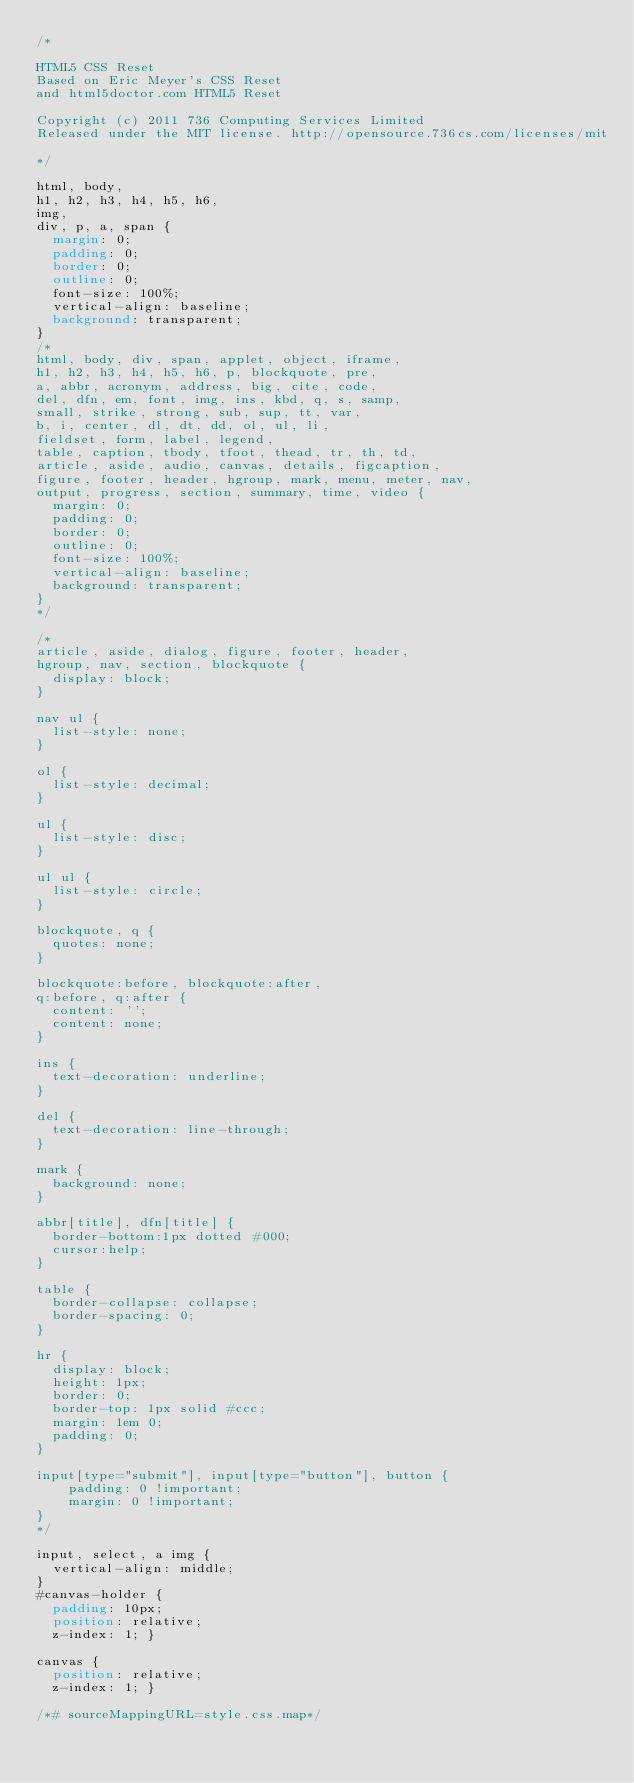<code> <loc_0><loc_0><loc_500><loc_500><_CSS_>/*

HTML5 CSS Reset
Based on Eric Meyer's CSS Reset
and html5doctor.com HTML5 Reset

Copyright (c) 2011 736 Computing Services Limited
Released under the MIT license. http://opensource.736cs.com/licenses/mit

*/

html, body,
h1, h2, h3, h4, h5, h6,
img,
div, p, a, span {
	margin: 0;
	padding: 0;
	border: 0;
	outline: 0;
	font-size: 100%;
	vertical-align: baseline;
	background: transparent;
}
/*
html, body, div, span, applet, object, iframe,
h1, h2, h3, h4, h5, h6, p, blockquote, pre,
a, abbr, acronym, address, big, cite, code,
del, dfn, em, font, img, ins, kbd, q, s, samp,
small, strike, strong, sub, sup, tt, var,
b, i, center, dl, dt, dd, ol, ul, li,
fieldset, form, label, legend,
table, caption, tbody, tfoot, thead, tr, th, td,
article, aside, audio, canvas, details, figcaption,
figure, footer, header, hgroup, mark, menu, meter, nav,
output, progress, section, summary, time, video {
	margin: 0;
	padding: 0;
	border: 0;
	outline: 0;
	font-size: 100%;
	vertical-align: baseline;
	background: transparent;
}
*/

/*
article, aside, dialog, figure, footer, header,
hgroup, nav, section, blockquote {
	display: block;
}

nav ul {
	list-style: none;
}

ol {
	list-style: decimal;
}

ul {
	list-style: disc;
}

ul ul {
	list-style: circle;
}

blockquote, q {
	quotes: none;
}

blockquote:before, blockquote:after,
q:before, q:after {
	content: '';
	content: none;
}

ins {
	text-decoration: underline;
}

del {
	text-decoration: line-through;
}

mark {
	background: none;
}

abbr[title], dfn[title] {
	border-bottom:1px dotted #000;
	cursor:help;
}

table {
	border-collapse: collapse;
	border-spacing: 0;
}

hr {
	display: block;
	height: 1px;
	border: 0;
	border-top: 1px solid #ccc;
	margin: 1em 0;
	padding: 0;
}

input[type="submit"], input[type="button"], button {
    padding: 0 !important;
    margin: 0 !important;
}
*/

input, select, a img {
	vertical-align: middle;
}
#canvas-holder {
  padding: 10px;
  position: relative;
  z-index: 1; }

canvas {
  position: relative;
  z-index: 1; }

/*# sourceMappingURL=style.css.map*/</code> 